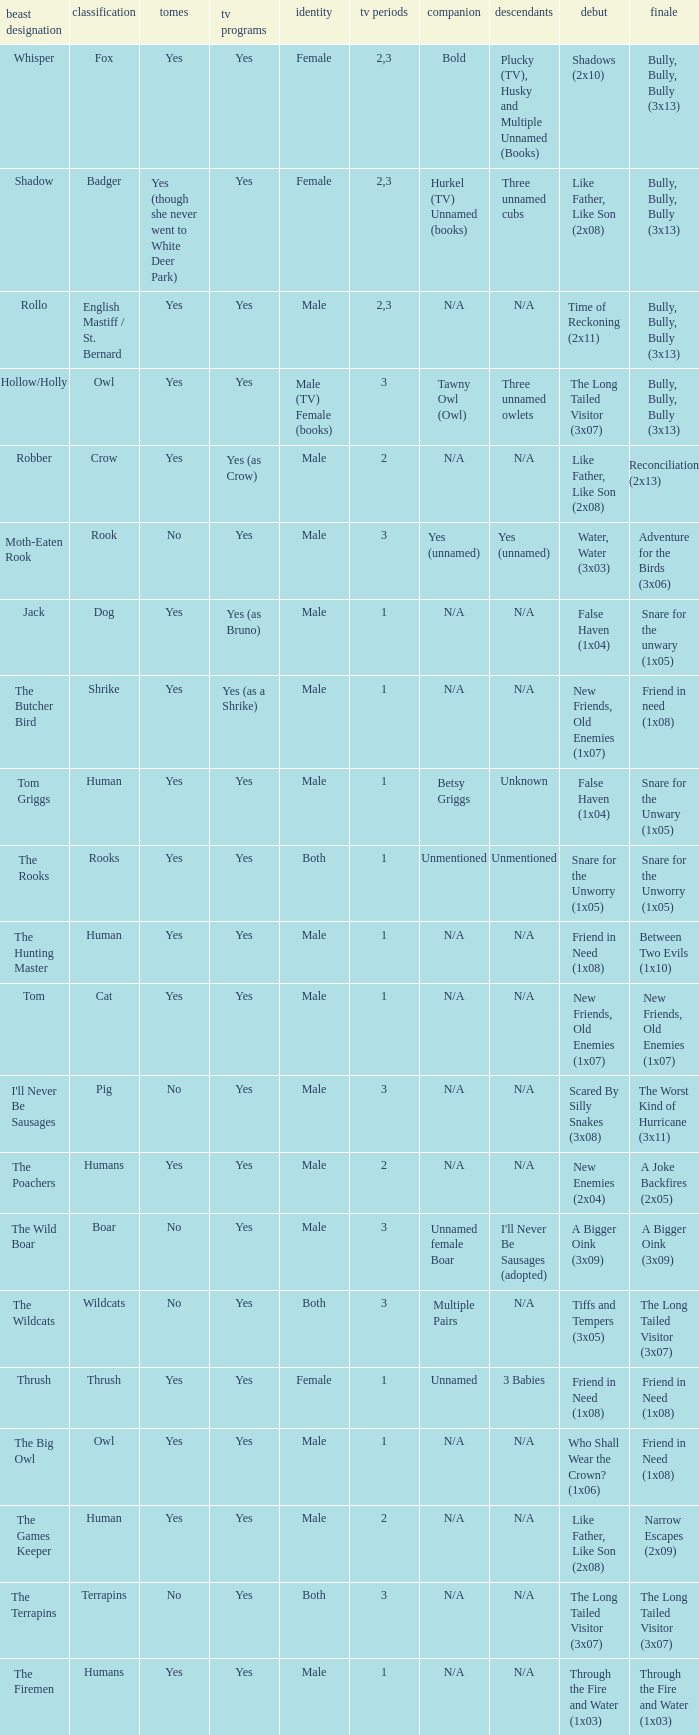What show has a boar? Yes. 